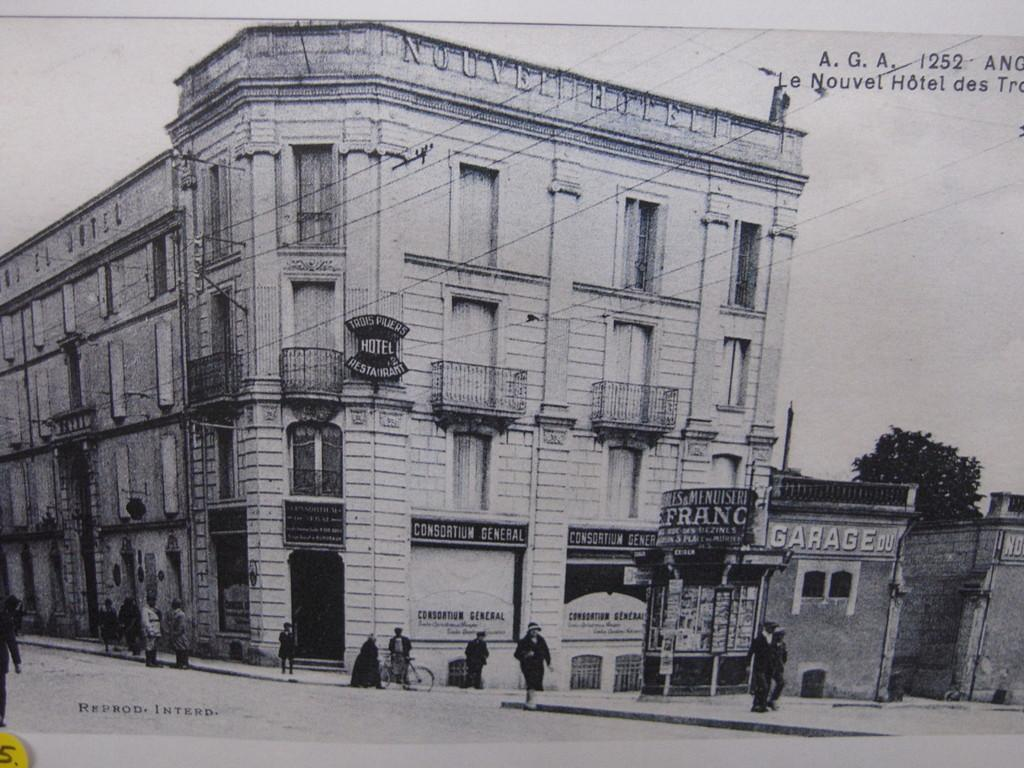What type of visual is the image? The image is a poster. What can be found on the poster? There is information on the poster. What structure is visible in the image? There is a building visible in the image. What type of objects are present in the image? There are boards, people, a tree, a bicycle, a road, and other objects in the image. What type of jewel is being stored in the box in the image? There is no box or jewel present in the image. Can you tell me how many frogs are sitting on the bicycle in the image? There are no frogs present in the image, and therefore no such activity can be observed. 